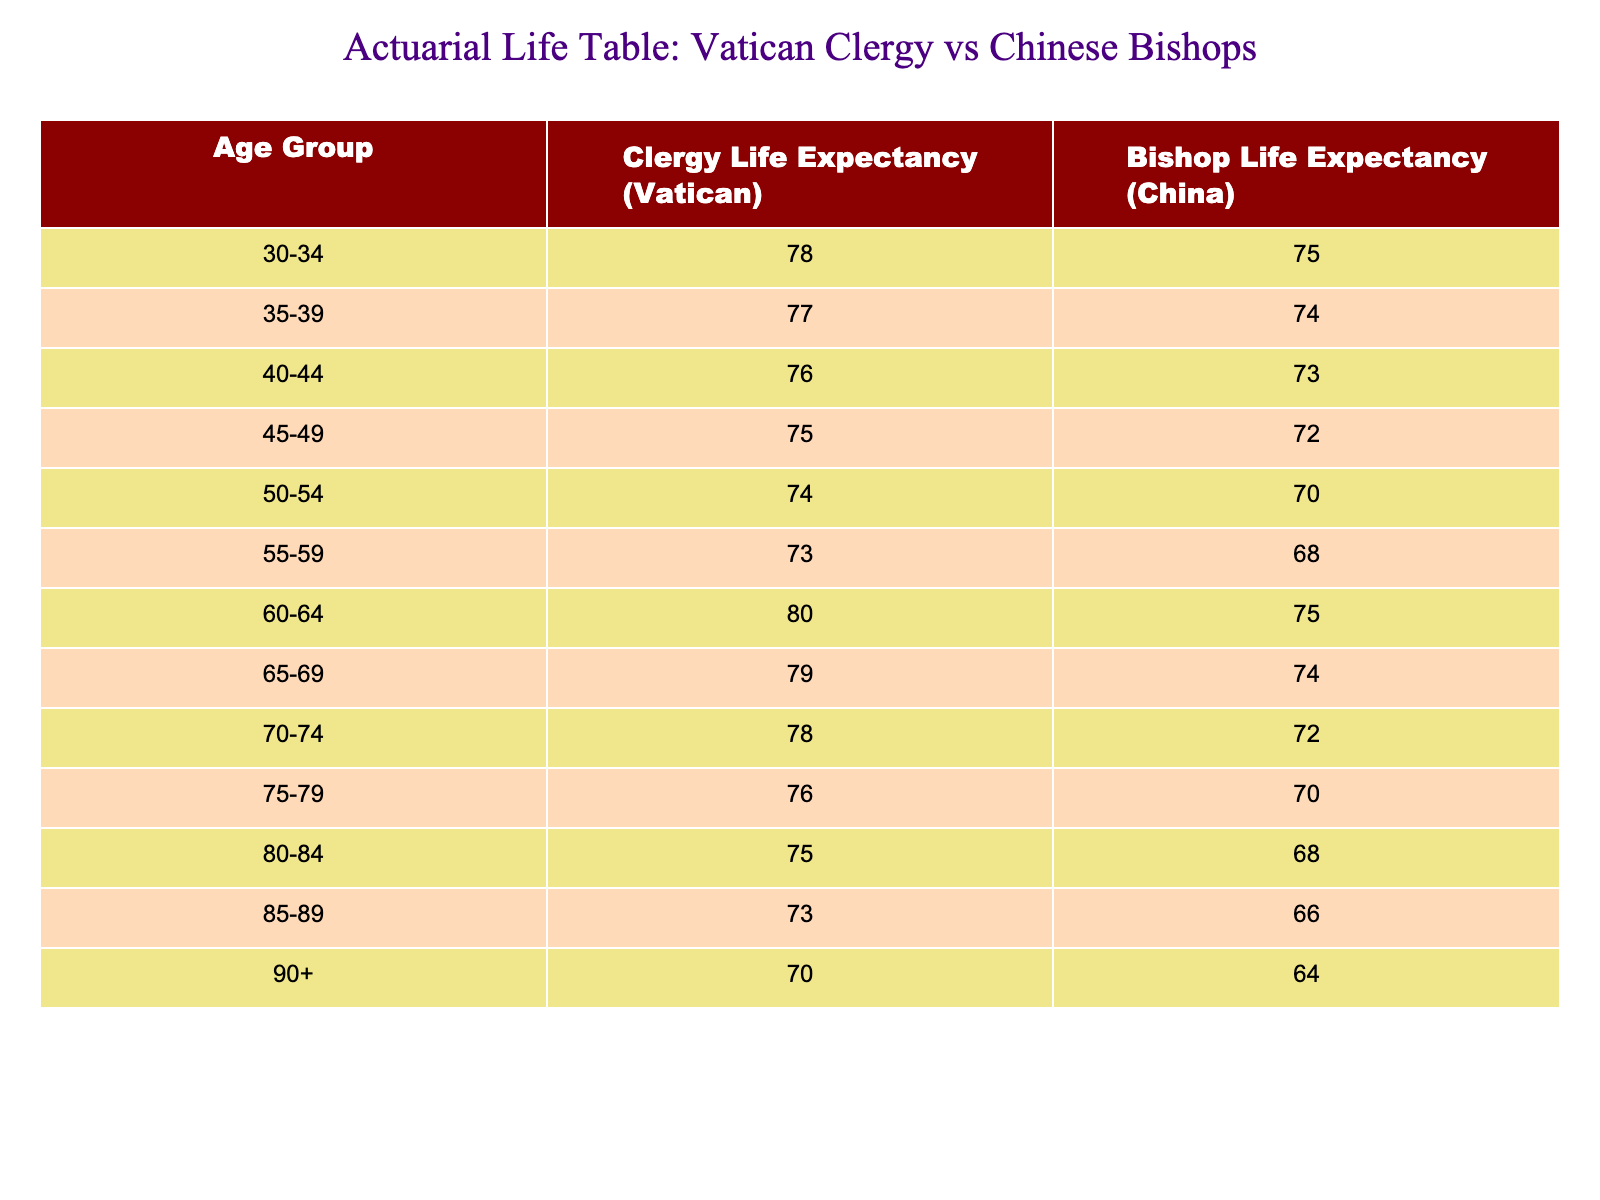What is the life expectancy of clergy members aged 50-54 in the Vatican? According to the table, the life expectancy for clergy members aged 50-54 in the Vatican is explicitly listed as 74 years.
Answer: 74 What is the difference in life expectancy for bishops aged 60-64 between the Vatican and China? The life expectancy for bishops aged 60-64 in the Vatican is 80 years, while in China it is 75 years. The difference is calculated as 80 - 75 = 5 years.
Answer: 5 Do clergy members in the Vatican have a higher life expectancy than bishops in China in the age group 75-79? Yes, the life expectancy for clergy members in the Vatican is 76 years, while for bishops in China, it is 70 years, thus confirming that clergy members in the Vatican have a higher life expectancy in this age group.
Answer: Yes What is the average life expectancy for clergy members in the Vatican across all age groups? To calculate the average, we sum all life expectancy values for the Vatican: 78 + 77 + 76 + 75 + 74 + 73 + 80 + 79 + 78 + 76 + 75 + 73 + 70 = 1,020. There are 13 age groups, so the average is 1,020 / 13 = approximately 78.46 years, which can be rounded to 78.5 years.
Answer: 78.5 How does the life expectancy of the oldest age group (90+) compare between clergy members in the Vatican and bishops in China? The table lists the life expectancy for the 90+ age group as 70 years for the Vatican and 64 years for China. Thus, clergy members in the Vatican have a higher life expectancy by 6 years in this age group.
Answer: Higher by 6 years What is the life expectancy for the youngest age group (30-34) of bishops in China? The table shows that the life expectancy for bishops aged 30-34 in China is 75 years.
Answer: 75 Are there any age groups where the life expectancy of clergy in the Vatican is less than that of bishops in China? Yes, when we review the table, clergy members in the Vatican have lower life expectancy compared to bishops in China for the age groups 50-54, 55-59, 60-64, and 65-69, indicating that Vatican clergy have shorter life expectancy in these age brackets.
Answer: Yes What is the highest life expectancy recorded for bishops in China across the age groups? By examining the table, the highest life expectancy for bishops in China is seen in the age group 30-34, which is 75 years.
Answer: 75 What is the overall trend in life expectancy for clergy in the Vatican as age increases? The data indicates that as the age increases among clergy in the Vatican, life expectancy declines generally for most age groups except for the 60-64 age group, which records the highest value, suggesting a possible stabilization or improvement before decline.
Answer: Decline generally but with a peak at 60-64 